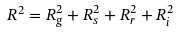Convert formula to latex. <formula><loc_0><loc_0><loc_500><loc_500>R ^ { 2 } = R _ { g } ^ { 2 } + R _ { s } ^ { 2 } + R _ { r } ^ { 2 } + R _ { i } ^ { 2 }</formula> 